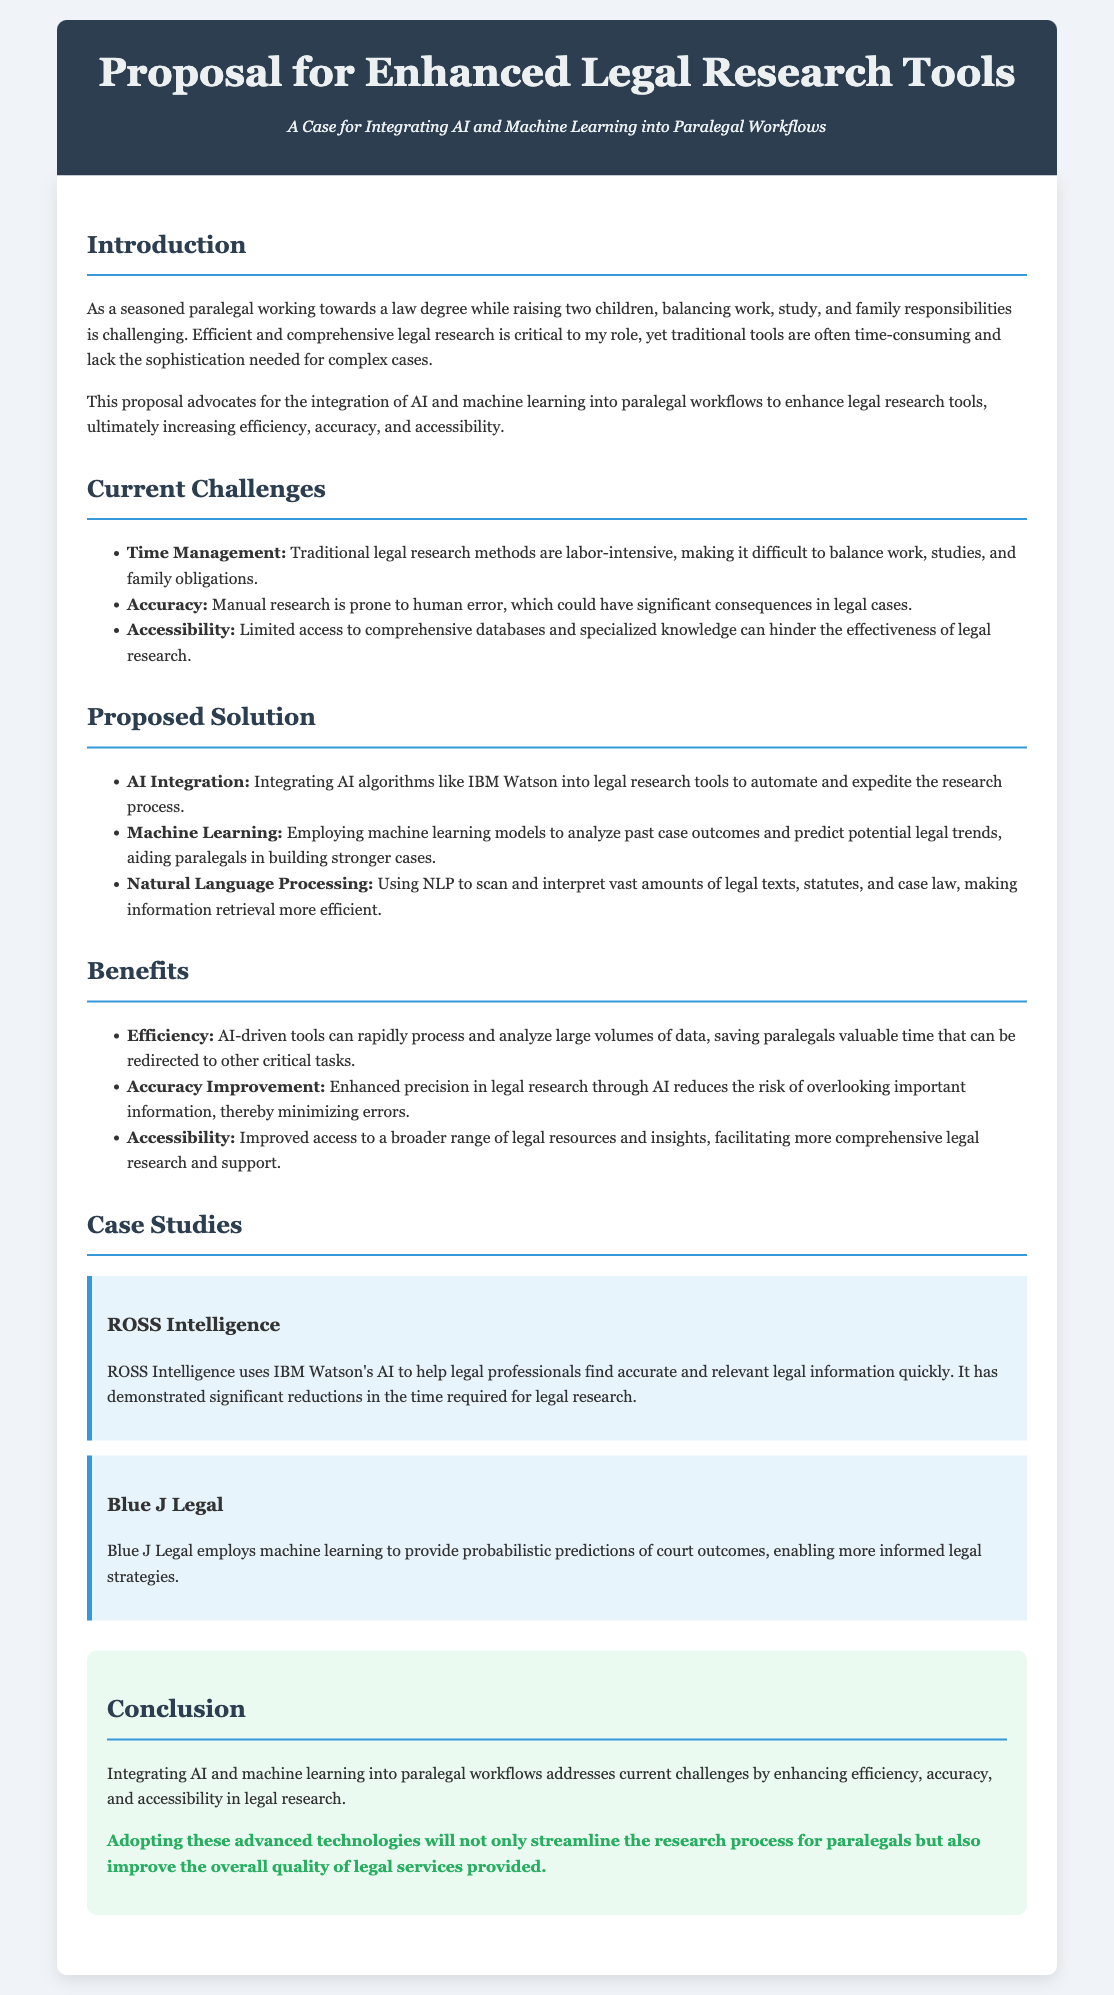What is the title of the proposal? The title of the proposal is clearly stated at the top of the document.
Answer: Proposal for Enhanced Legal Research Tools What technology does ROSS Intelligence utilize? ROSS Intelligence uses IBM Watson's AI for legal research.
Answer: IBM Watson What are the three current challenges highlighted? The document lists several challenges and focuses on three of them specifically.
Answer: Time Management, Accuracy, Accessibility What is one benefit of integrating AI into legal research? The proposal outlines multiple benefits of AI integration, emphasizing its impact on legal research efficiency.
Answer: Efficiency What does NLP stand for? The term is mentioned in the proposed solution section pertaining to technology that enhances legal research.
Answer: Natural Language Processing According to the proposal, what is one specific machine learning application? The proposal discusses various applications of machine learning in aiding legal workflows.
Answer: Predicting potential legal trends How many case studies are presented in the proposal? The section specifically highlights instances of AI and machine learning in practice, counting them to understand their number.
Answer: Two What is the main aim of this proposal? The proposal's main goal is outlined in the introduction regarding the enhancement of paralegal workflows.
Answer: Integration of AI and machine learning What kind of professionals could benefit from this proposal? The proposal indicates who would gain from the improved tools discussed, addressing a specific role in the legal field.
Answer: Paralegals 